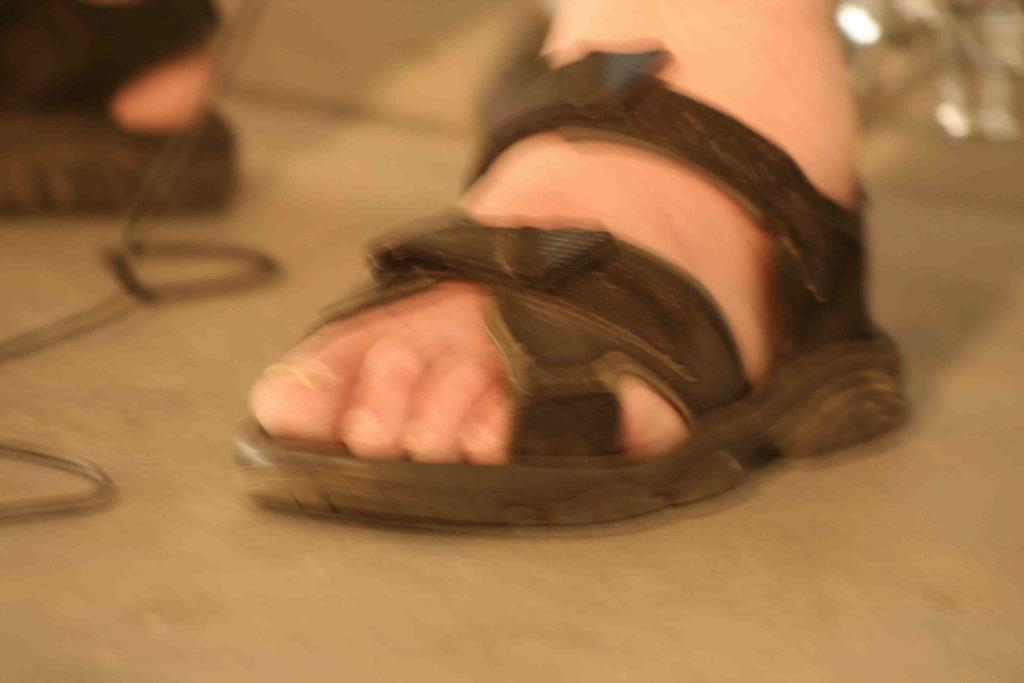What part of a person's body is visible in the image? The image contains a person's legs. What type of footwear is the person wearing? The person is wearing black-colored footwear. What is the person's skin color in the image? The image only shows the person's legs and black-colored footwear, so it is not possible to determine the person's skin color from the image. 